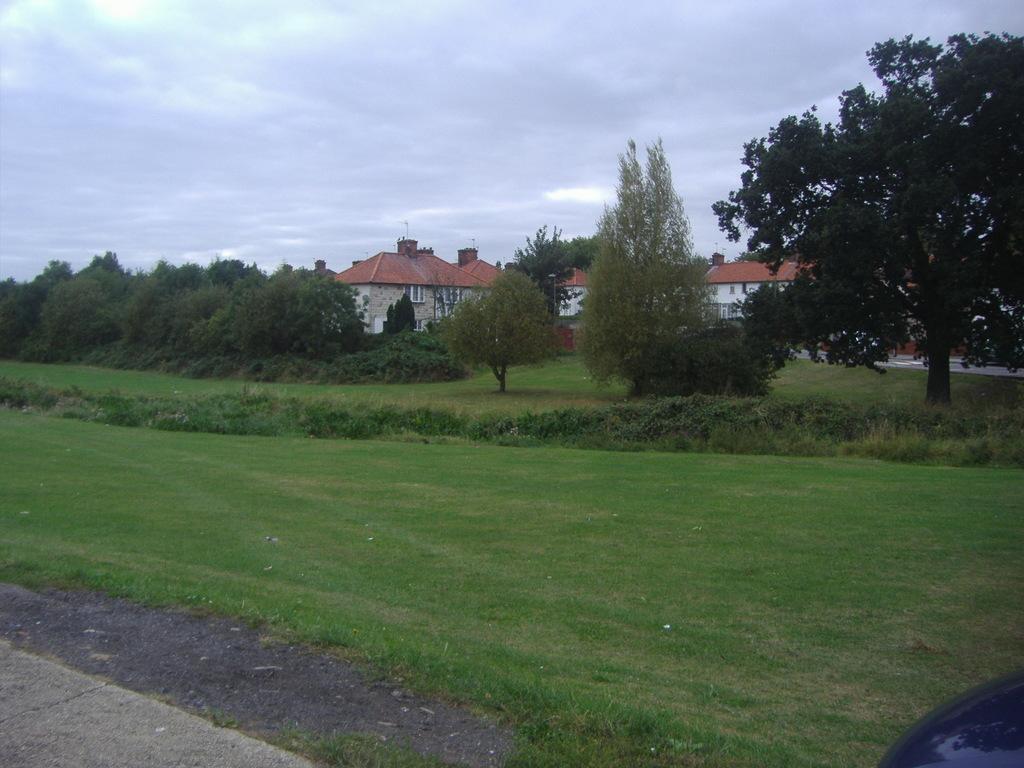In one or two sentences, can you explain what this image depicts? In this picture we can see some grass on the ground. There are few plants from left to right. We can see some trees and houses in the background. Sky is cloudy. 